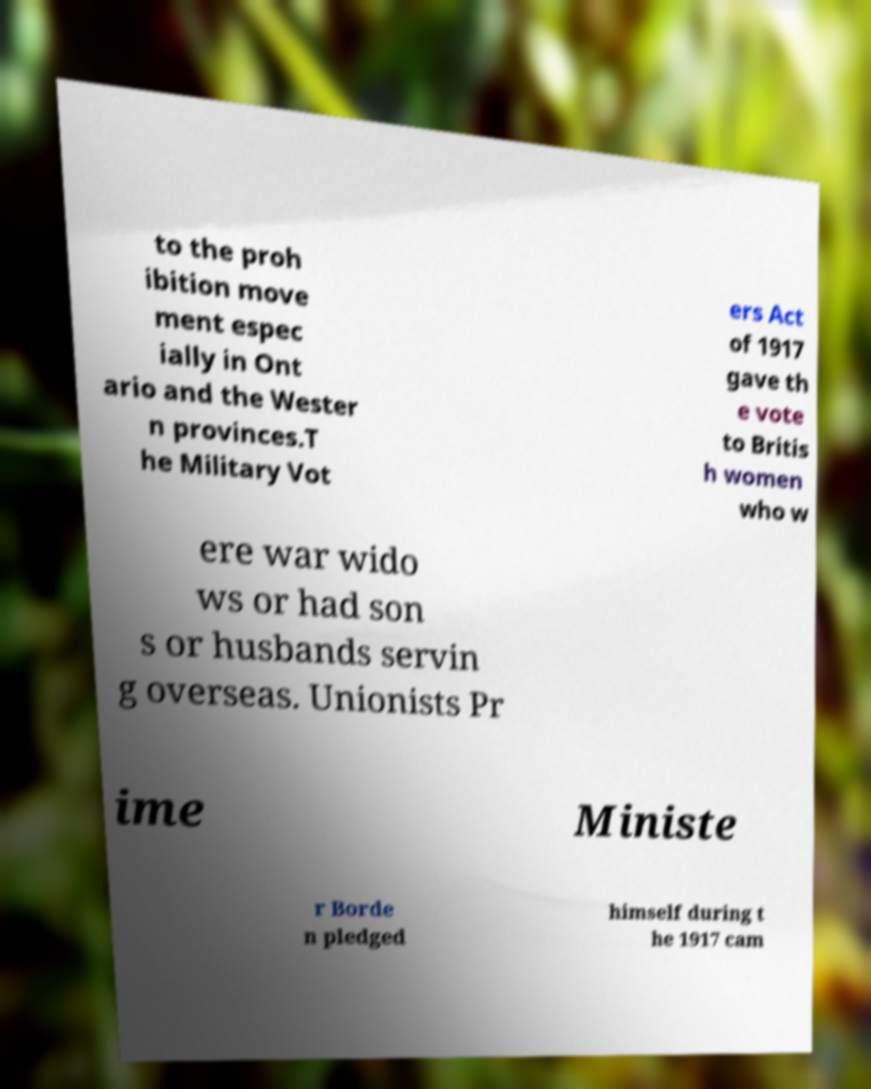Can you accurately transcribe the text from the provided image for me? to the proh ibition move ment espec ially in Ont ario and the Wester n provinces.T he Military Vot ers Act of 1917 gave th e vote to Britis h women who w ere war wido ws or had son s or husbands servin g overseas. Unionists Pr ime Ministe r Borde n pledged himself during t he 1917 cam 